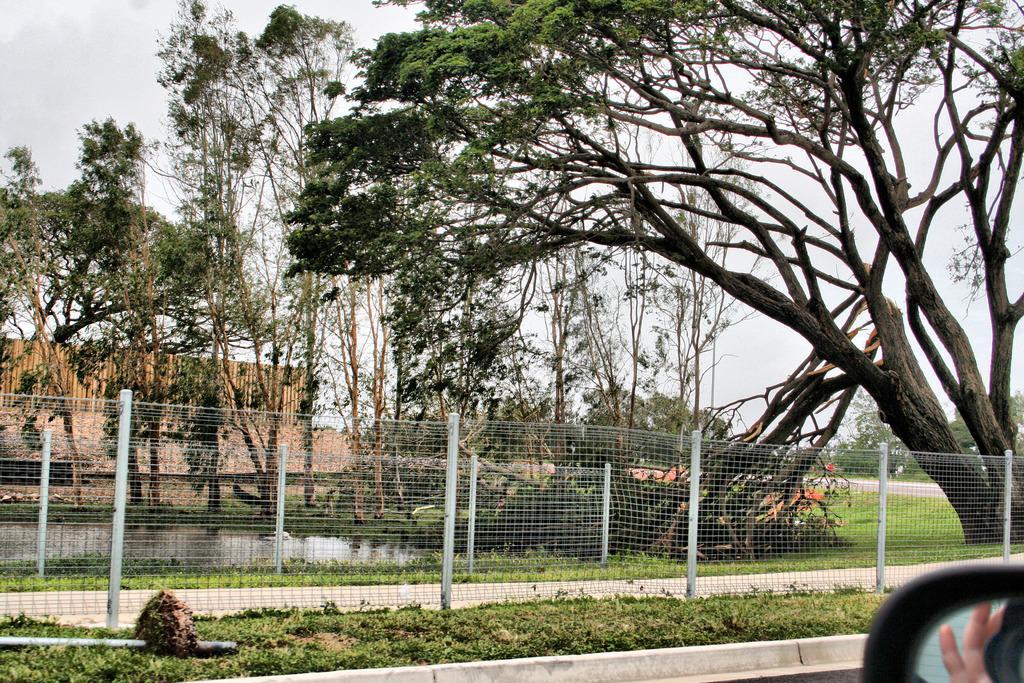Can you describe this image briefly? In this image I can see the side mirror of the car, some grass on the ground and metal fencing. In the background I can see few trees, the water, the wooden wall and the sky. 